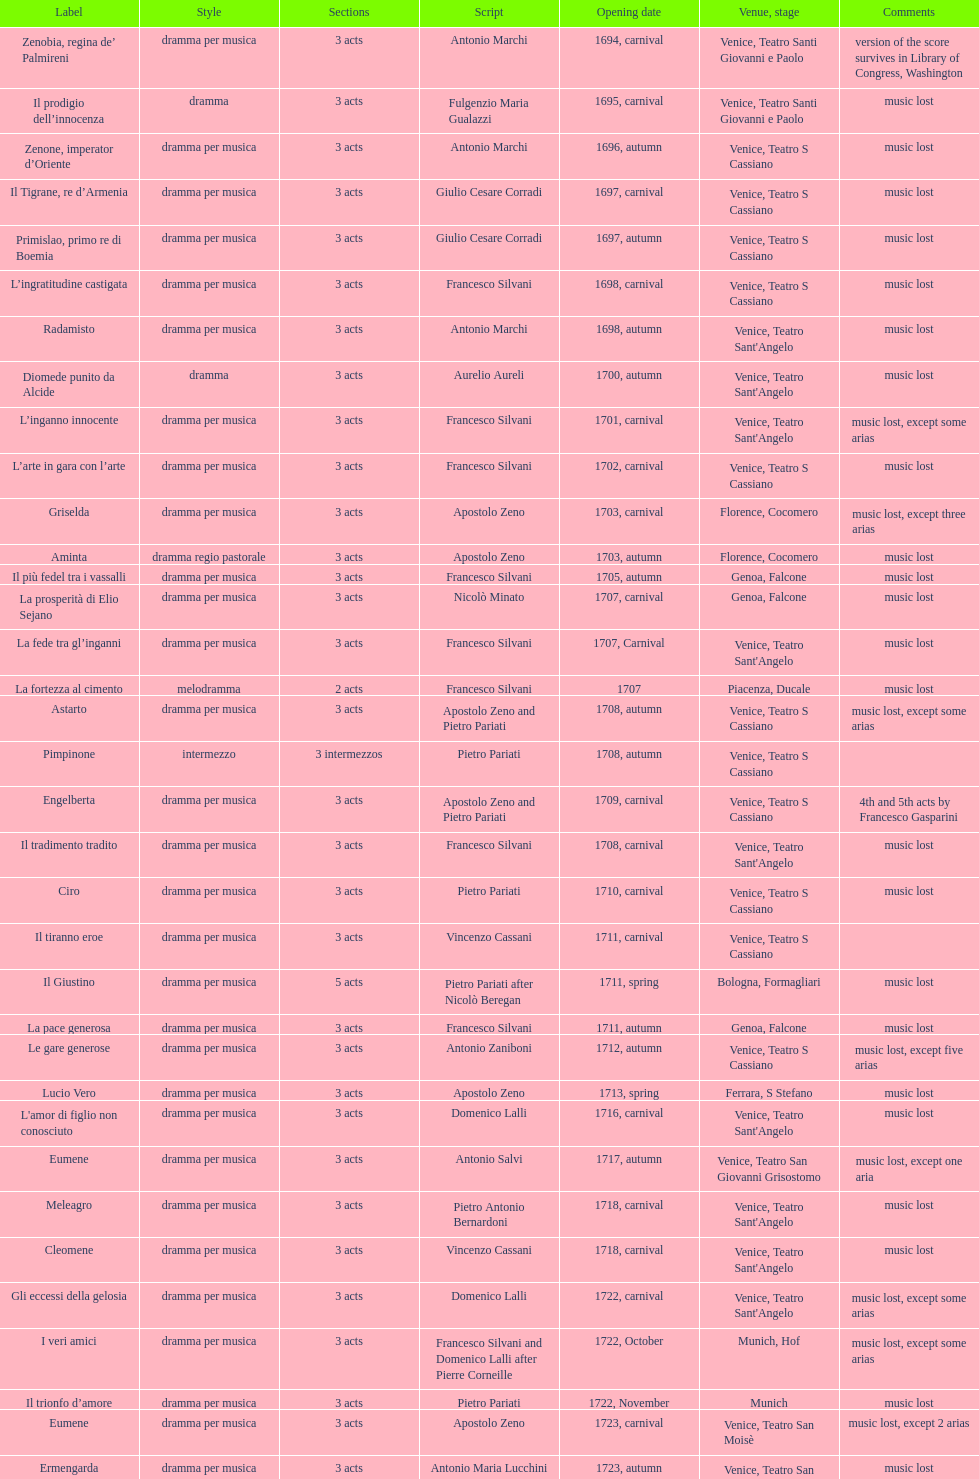What number of acts does il giustino have? 5. 